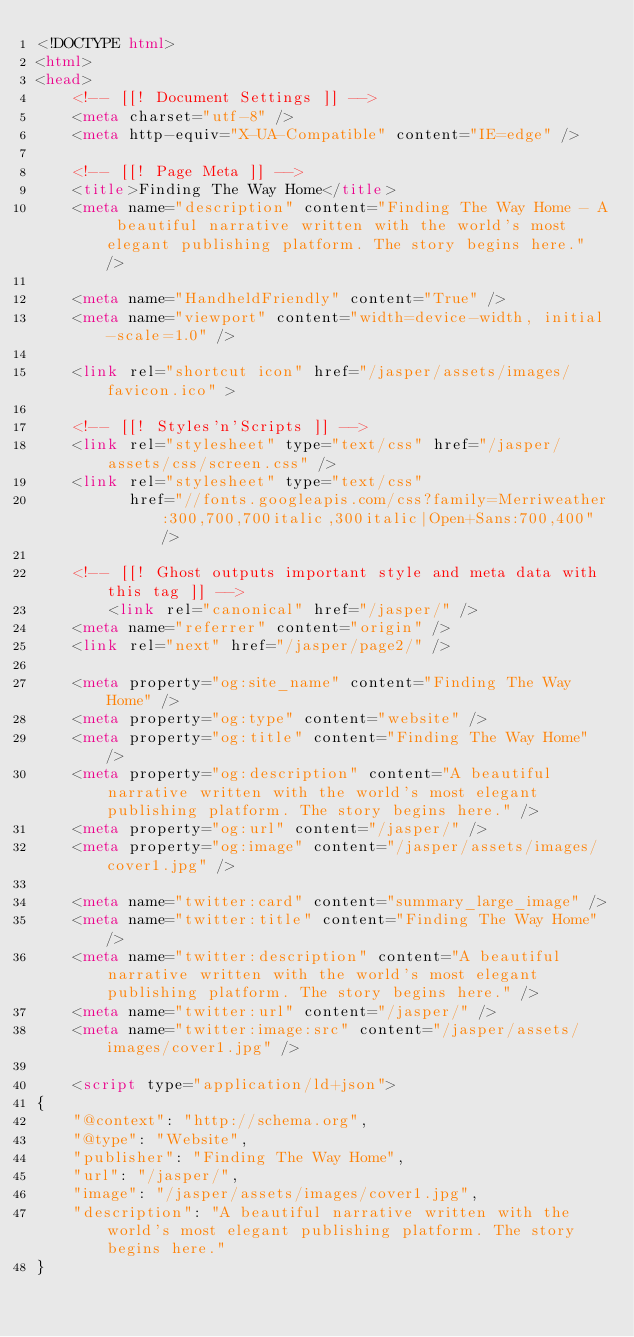<code> <loc_0><loc_0><loc_500><loc_500><_HTML_><!DOCTYPE html>
<html>
<head>
    <!-- [[! Document Settings ]] -->
    <meta charset="utf-8" />
    <meta http-equiv="X-UA-Compatible" content="IE=edge" />

    <!-- [[! Page Meta ]] -->
    <title>Finding The Way Home</title>
    <meta name="description" content="Finding The Way Home - A beautiful narrative written with the world's most elegant publishing platform. The story begins here." />

    <meta name="HandheldFriendly" content="True" />
    <meta name="viewport" content="width=device-width, initial-scale=1.0" />

    <link rel="shortcut icon" href="/jasper/assets/images/favicon.ico" >

    <!-- [[! Styles'n'Scripts ]] -->
    <link rel="stylesheet" type="text/css" href="/jasper/assets/css/screen.css" />
    <link rel="stylesheet" type="text/css"
          href="//fonts.googleapis.com/css?family=Merriweather:300,700,700italic,300italic|Open+Sans:700,400" />
    
    <!-- [[! Ghost outputs important style and meta data with this tag ]] -->
        <link rel="canonical" href="/jasper/" />
    <meta name="referrer" content="origin" />
    <link rel="next" href="/jasper/page2/" />

    <meta property="og:site_name" content="Finding The Way Home" />
    <meta property="og:type" content="website" />
    <meta property="og:title" content="Finding The Way Home" />
    <meta property="og:description" content="A beautiful narrative written with the world's most elegant publishing platform. The story begins here." />
    <meta property="og:url" content="/jasper/" />
    <meta property="og:image" content="/jasper/assets/images/cover1.jpg" />

    <meta name="twitter:card" content="summary_large_image" />
    <meta name="twitter:title" content="Finding The Way Home" />
    <meta name="twitter:description" content="A beautiful narrative written with the world's most elegant publishing platform. The story begins here." />
    <meta name="twitter:url" content="/jasper/" />
    <meta name="twitter:image:src" content="/jasper/assets/images/cover1.jpg" />

    <script type="application/ld+json">
{
    "@context": "http://schema.org",
    "@type": "Website",
    "publisher": "Finding The Way Home",
    "url": "/jasper/",
    "image": "/jasper/assets/images/cover1.jpg",
    "description": "A beautiful narrative written with the world's most elegant publishing platform. The story begins here."
}</code> 